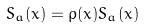<formula> <loc_0><loc_0><loc_500><loc_500>S _ { a } ( x ) = \rho ( x ) S _ { a } ( x )</formula> 